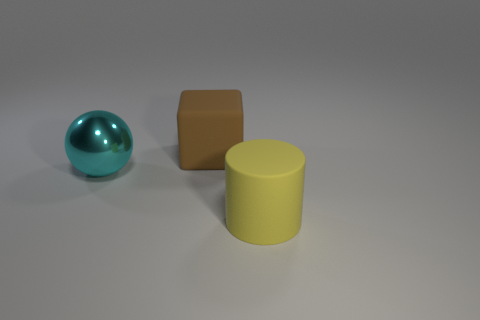Is there anything else that is the same material as the big cyan ball?
Ensure brevity in your answer.  No. There is a brown matte thing that is to the right of the large thing to the left of the big cube; is there a brown rubber thing that is left of it?
Provide a succinct answer. No. What number of yellow rubber things are the same size as the brown object?
Your answer should be very brief. 1. What is the material of the object that is right of the big matte object that is behind the big matte cylinder?
Your answer should be compact. Rubber. What is the shape of the big matte thing in front of the large rubber object behind the large object on the right side of the big brown matte cube?
Offer a terse response. Cylinder. Does the big thing in front of the big ball have the same shape as the large rubber object behind the cylinder?
Keep it short and to the point. No. How many other things are there of the same material as the big cylinder?
Your answer should be very brief. 1. What shape is the big thing that is made of the same material as the large brown block?
Make the answer very short. Cylinder. Do the brown object and the yellow object have the same size?
Give a very brief answer. Yes. How big is the matte object that is to the left of the matte object that is in front of the brown matte block?
Provide a succinct answer. Large. 